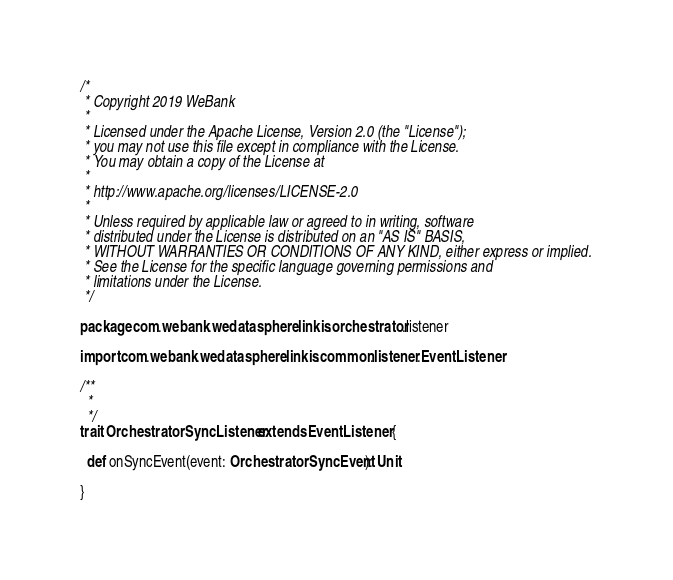<code> <loc_0><loc_0><loc_500><loc_500><_Scala_>/*
 * Copyright 2019 WeBank
 *
 * Licensed under the Apache License, Version 2.0 (the "License");
 * you may not use this file except in compliance with the License.
 * You may obtain a copy of the License at
 *
 * http://www.apache.org/licenses/LICENSE-2.0
 *
 * Unless required by applicable law or agreed to in writing, software
 * distributed under the License is distributed on an "AS IS" BASIS,
 * WITHOUT WARRANTIES OR CONDITIONS OF ANY KIND, either express or implied.
 * See the License for the specific language governing permissions and
 * limitations under the License.
 */

package com.webank.wedatasphere.linkis.orchestrator.listener

import com.webank.wedatasphere.linkis.common.listener.EventListener

/**
  *
  */
trait OrchestratorSyncListener extends EventListener {

  def onSyncEvent(event: OrchestratorSyncEvent): Unit

}
</code> 